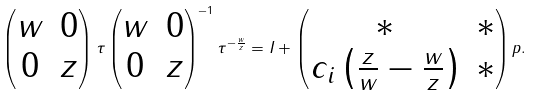Convert formula to latex. <formula><loc_0><loc_0><loc_500><loc_500>\begin{pmatrix} w & 0 \\ 0 & z \end{pmatrix} \tau \begin{pmatrix} w & 0 \\ 0 & z \end{pmatrix} ^ { - 1 } \tau ^ { - \frac { w } { z } } = I + \begin{pmatrix} * & * \\ c _ { i } \left ( \frac { z } { w } - \frac { w } { z } \right ) & * \end{pmatrix} p .</formula> 